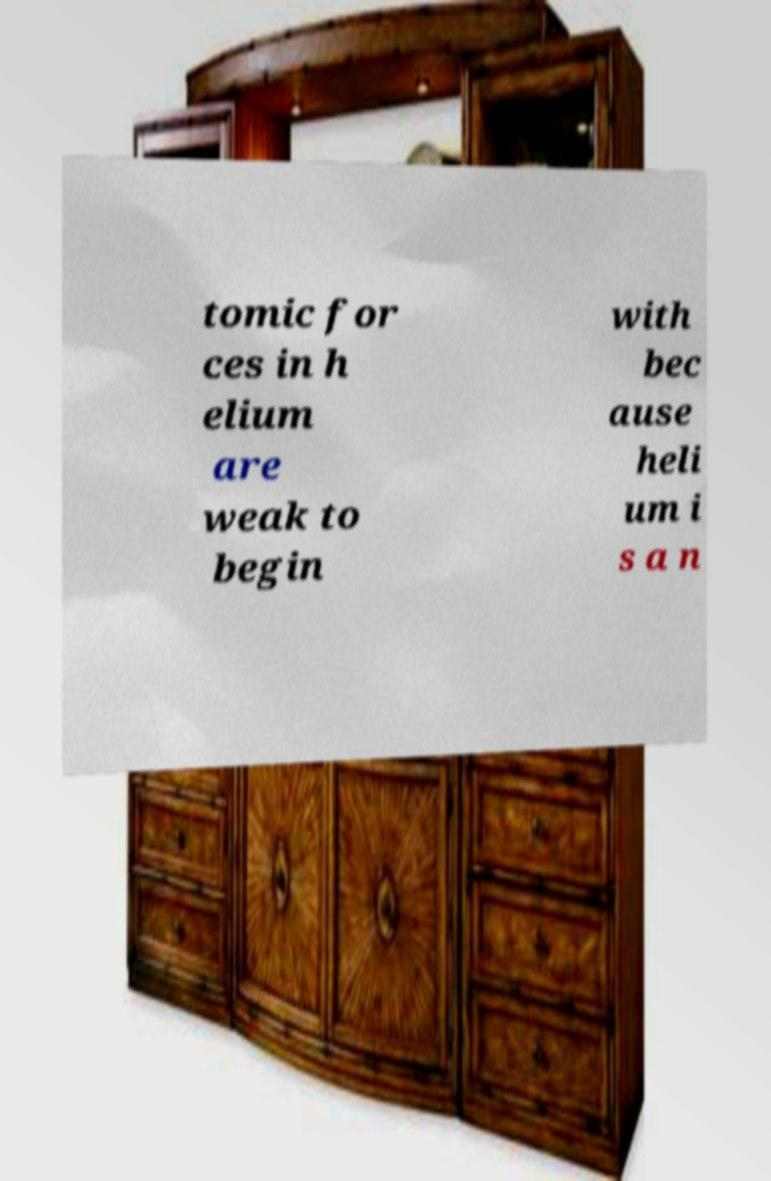Please identify and transcribe the text found in this image. tomic for ces in h elium are weak to begin with bec ause heli um i s a n 